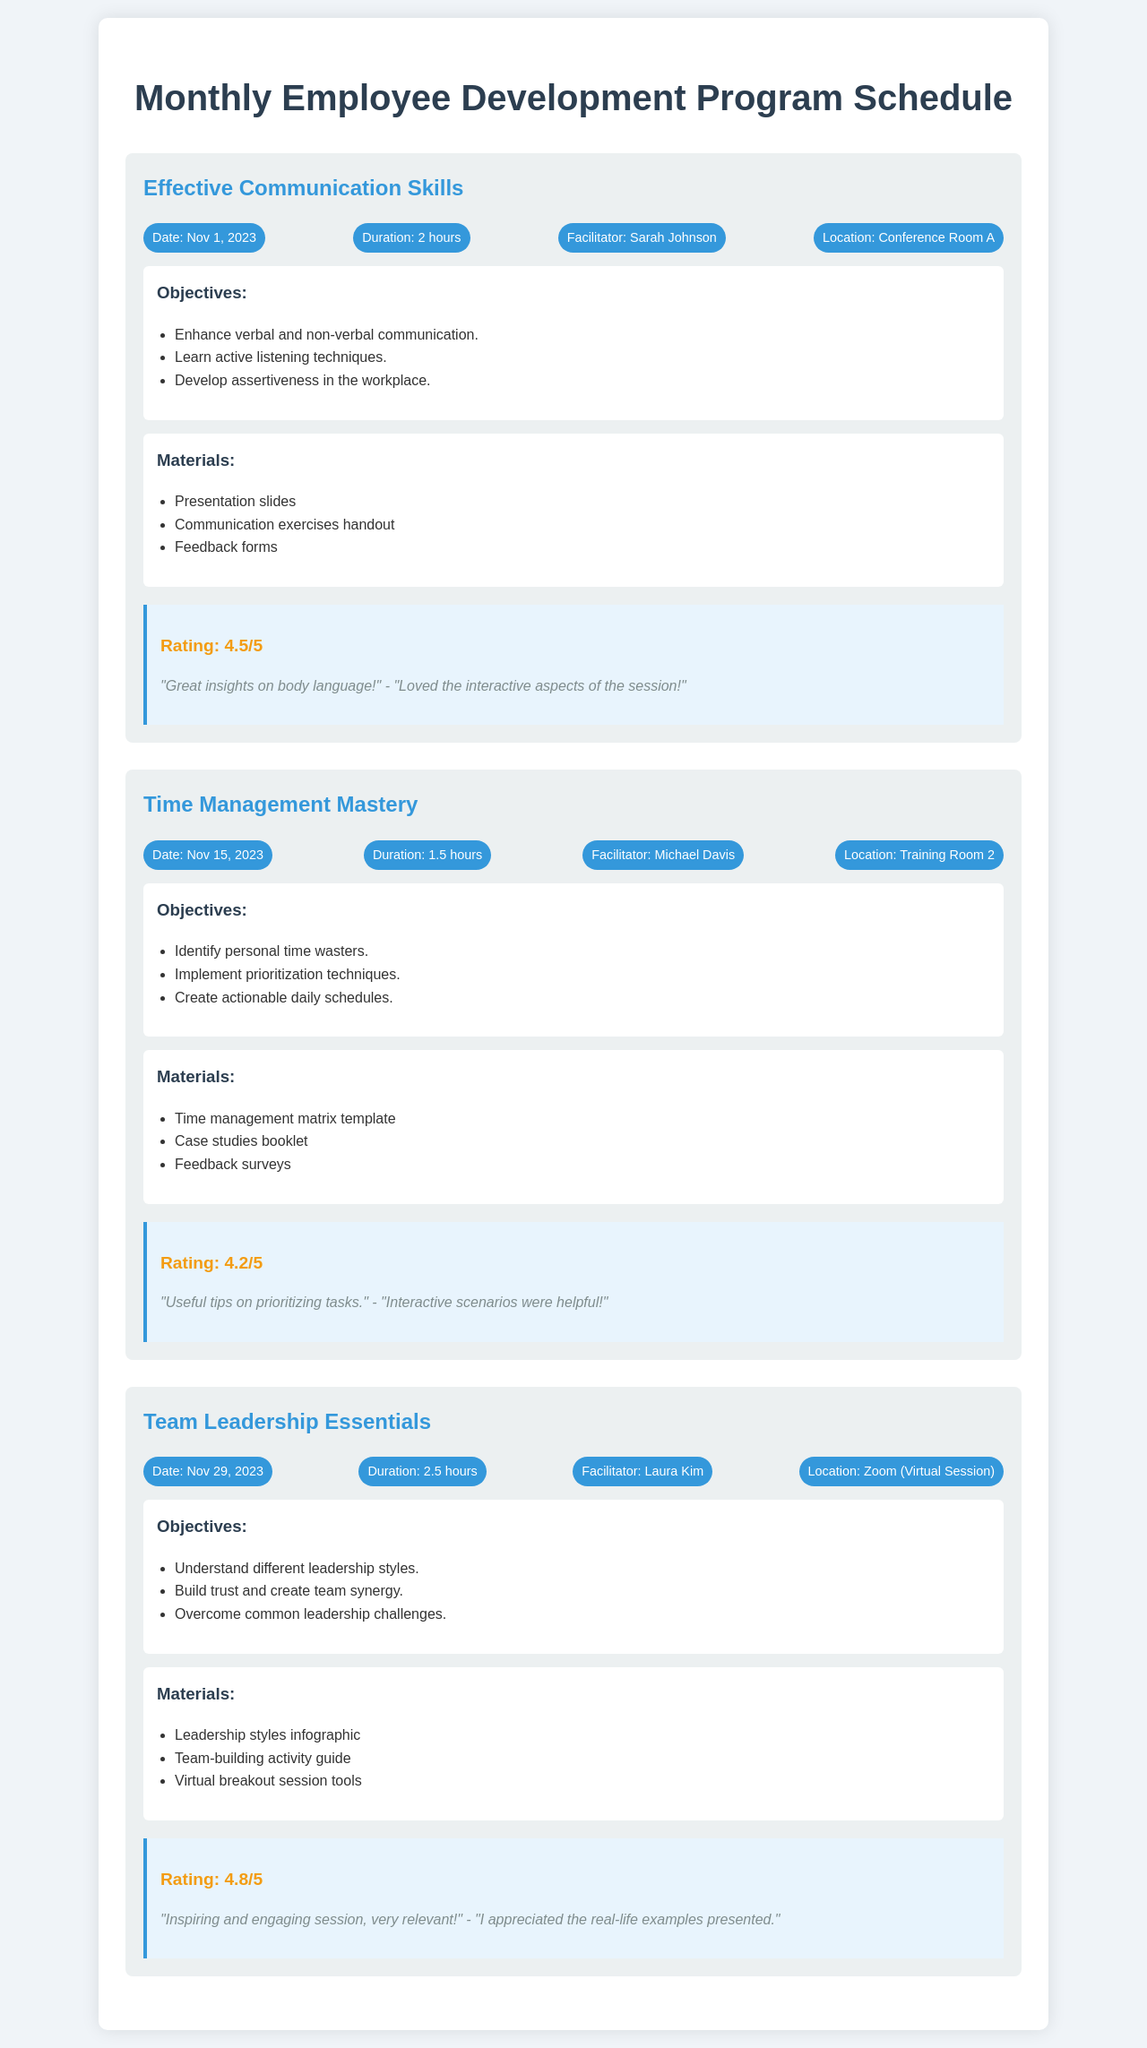What is the date of the Effective Communication Skills session? The document provides the date for this session as November 1, 2023.
Answer: November 1, 2023 Who is the facilitator for the Time Management Mastery session? The document specifies Michael Davis as the facilitator for this session.
Answer: Michael Davis How long is the Team Leadership Essentials session? The duration of the Team Leadership Essentials session is mentioned as 2.5 hours.
Answer: 2.5 hours What rating did the participants give the Time Management Mastery session? The document states the rating for this session as 4.2 out of 5, according to participant feedback.
Answer: 4.2/5 Which session is conducted virtually? The document indicates that the Team Leadership Essentials session is held via Zoom, making it a virtual session.
Answer: Zoom (Virtual Session) What is one objective of the Effective Communication Skills session? The document lists several objectives, one of which is to enhance verbal and non-verbal communication.
Answer: Enhance verbal and non-verbal communication Name one material used in the Team Leadership Essentials session. The document mentions a leadership styles infographic as one of the materials for this session.
Answer: Leadership styles infographic How many feedback comments are provided for the Effective Communication Skills session? The document includes two comments from participants regarding the Effective Communication Skills session.
Answer: Two comments 